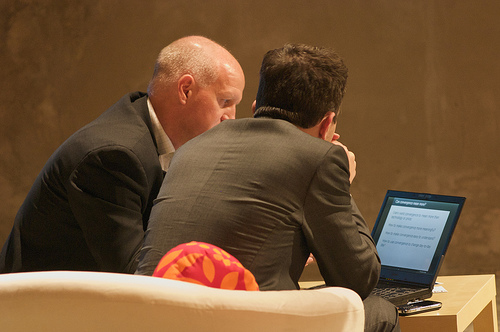What is the mood conveyed by the image? The image conveys a mood of focused concentration and perhaps discussion of serious matters, judging by the body language and facial expressions of the individuals. 